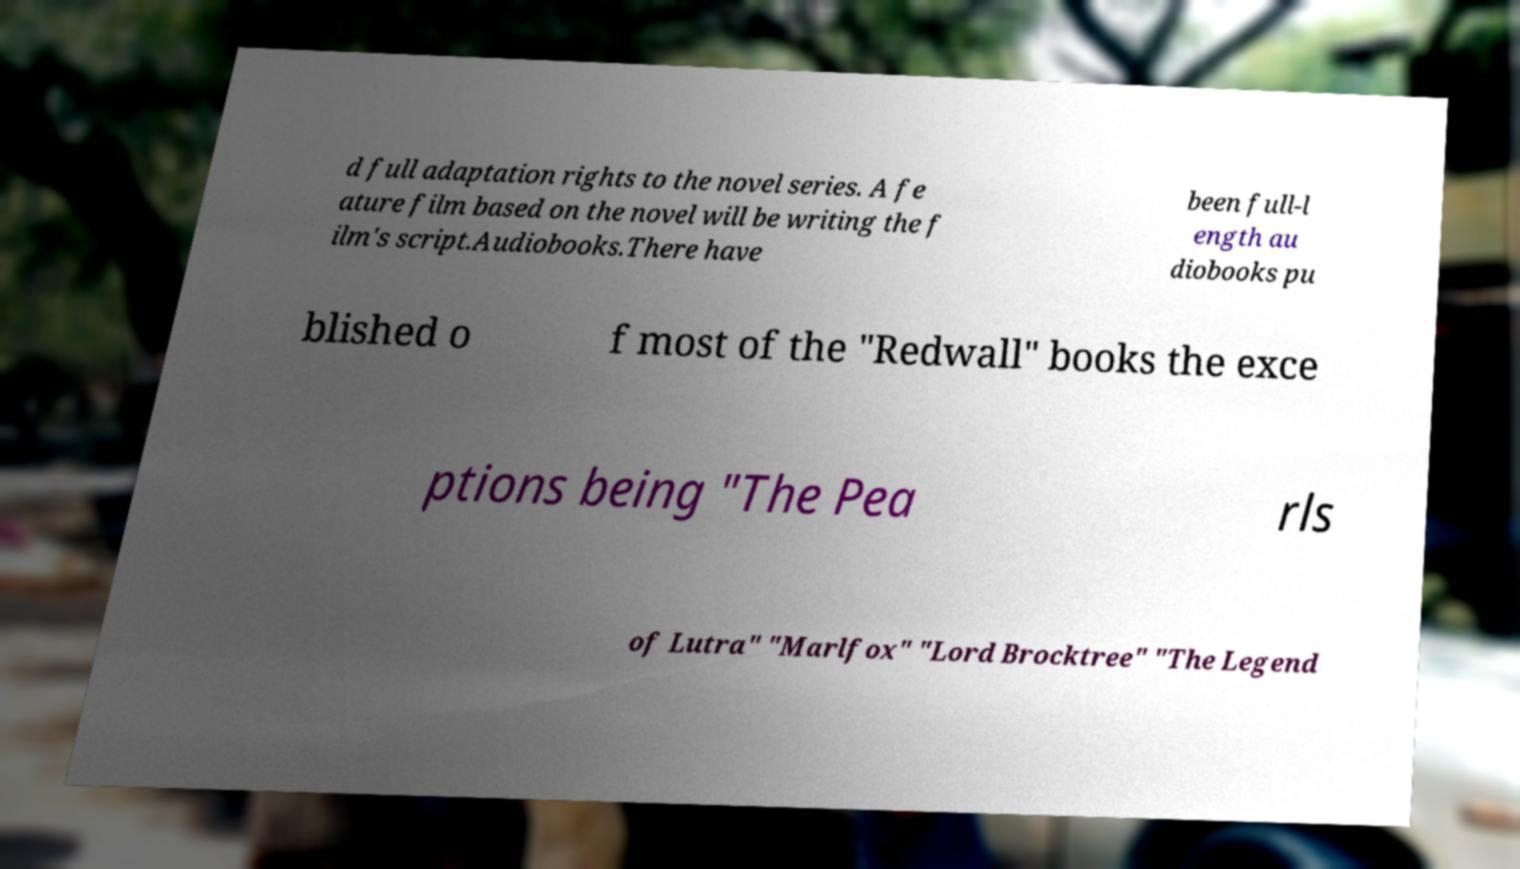There's text embedded in this image that I need extracted. Can you transcribe it verbatim? d full adaptation rights to the novel series. A fe ature film based on the novel will be writing the f ilm's script.Audiobooks.There have been full-l ength au diobooks pu blished o f most of the "Redwall" books the exce ptions being "The Pea rls of Lutra" "Marlfox" "Lord Brocktree" "The Legend 